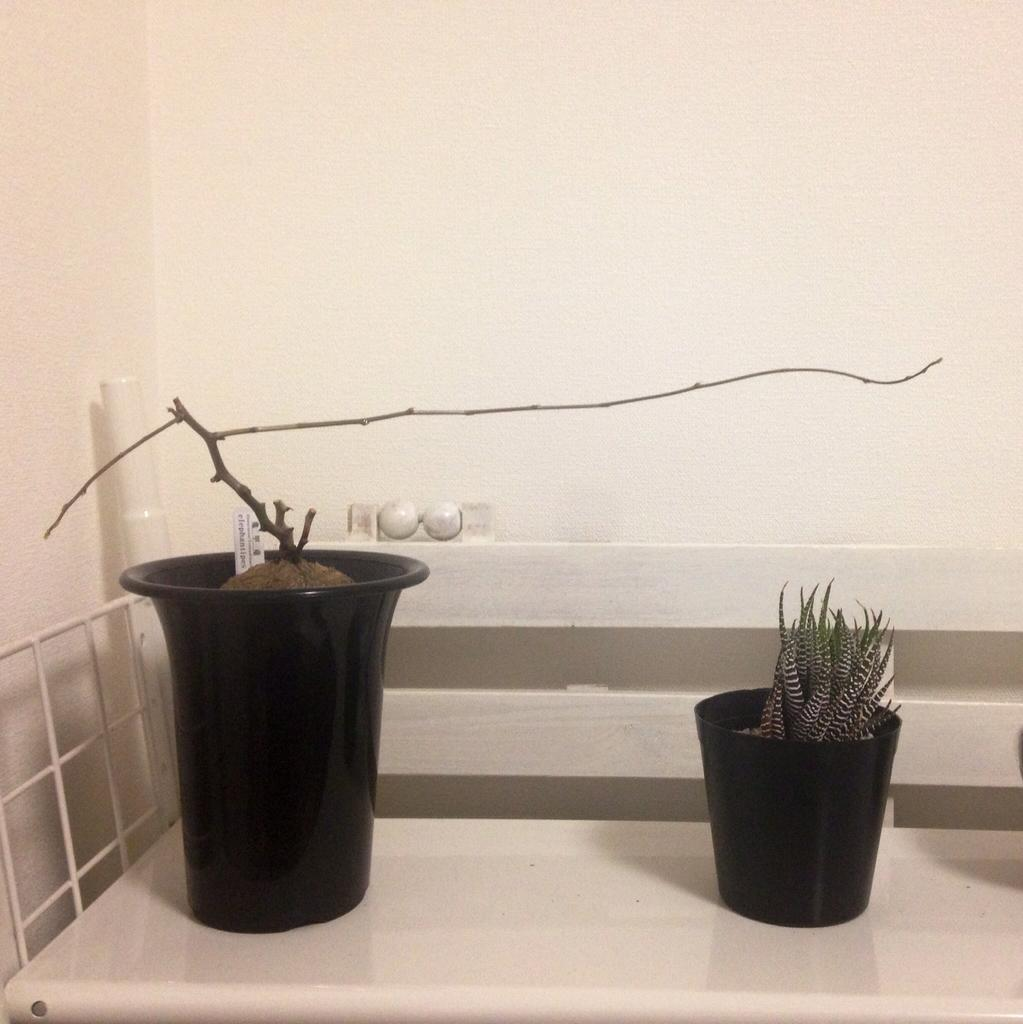What type of plants can be seen in the image? There are houseplants in the image. What is the color of the surface on which the houseplants are placed? The houseplants are on a white surface. What can be seen behind the houseplants in the image? There is a wall visible behind the houseplants. What is located on the left side of the image? There is a metal grill on the left side of the image. What type of watch is the houseplant wearing in the image? There are no watches present in the image, as houseplants do not wear accessories. 